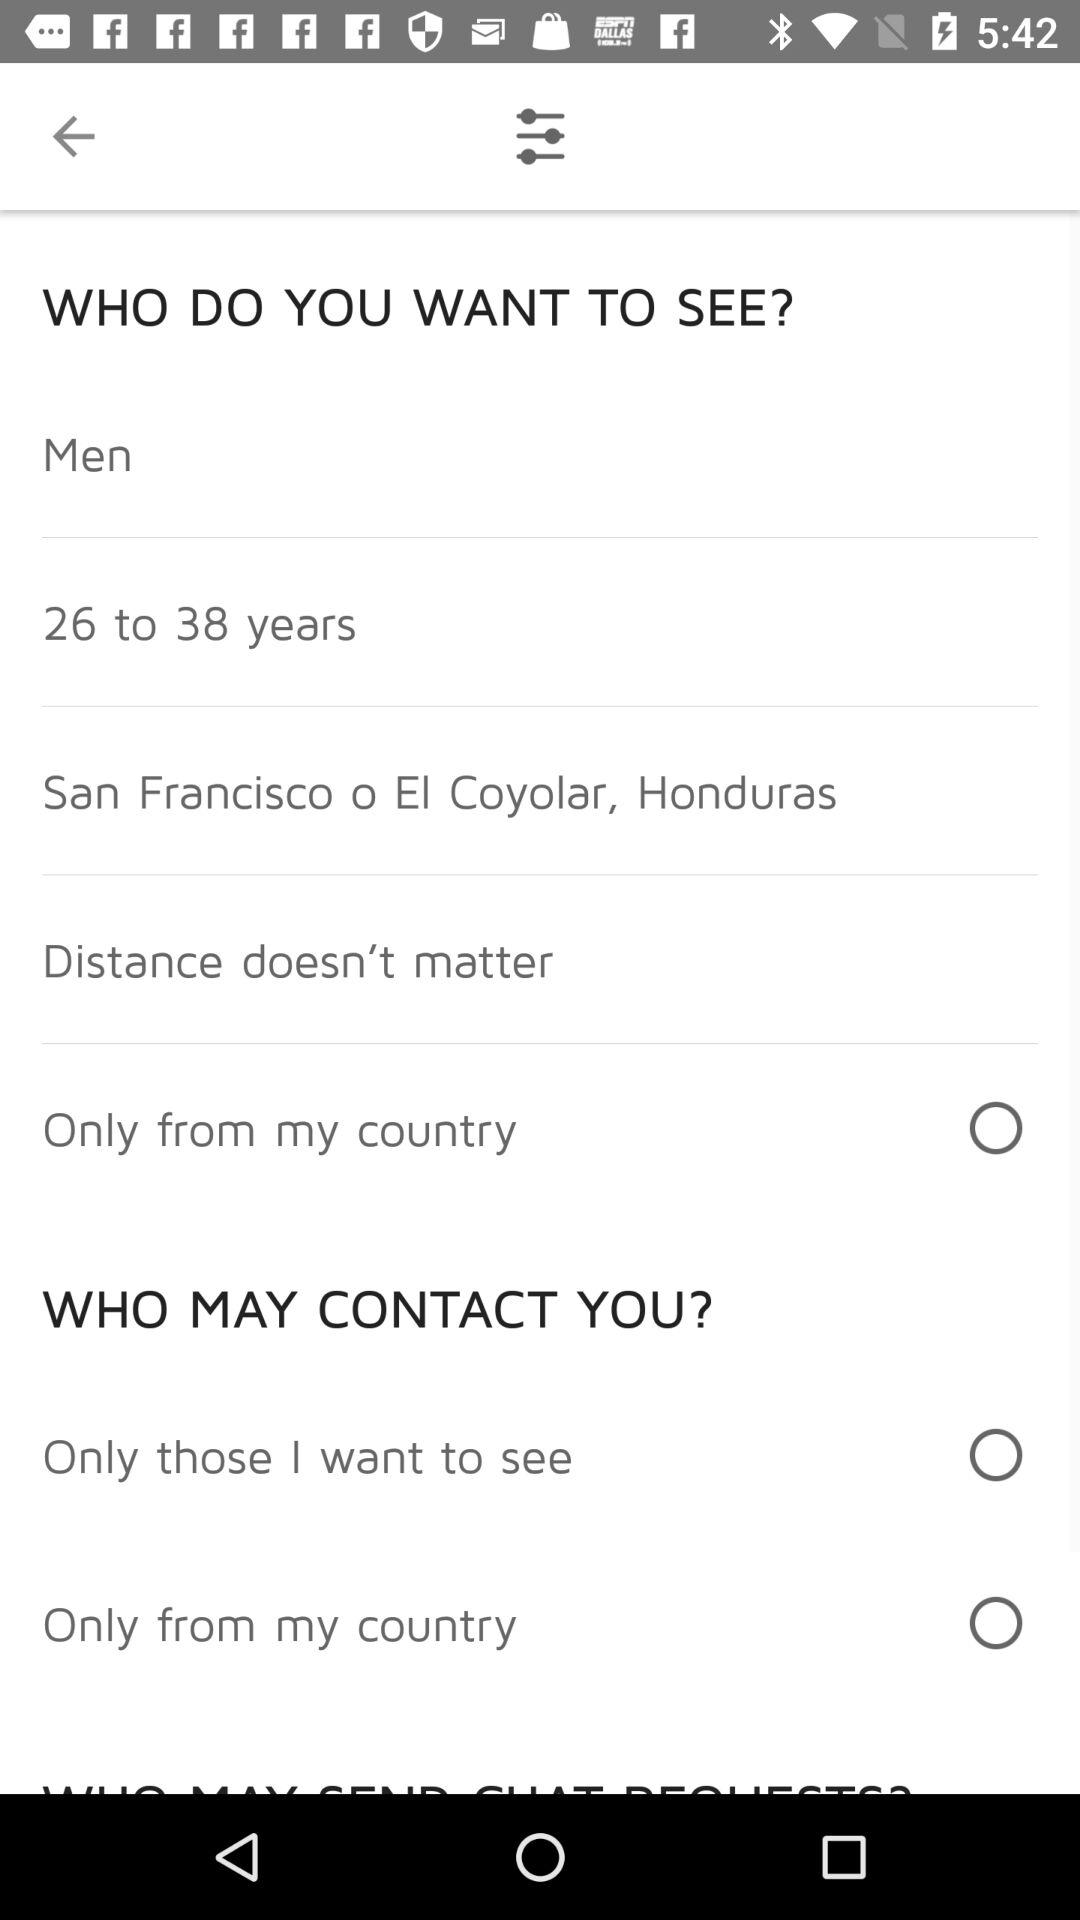What country is the user from?
When the provided information is insufficient, respond with <no answer>. <no answer> 